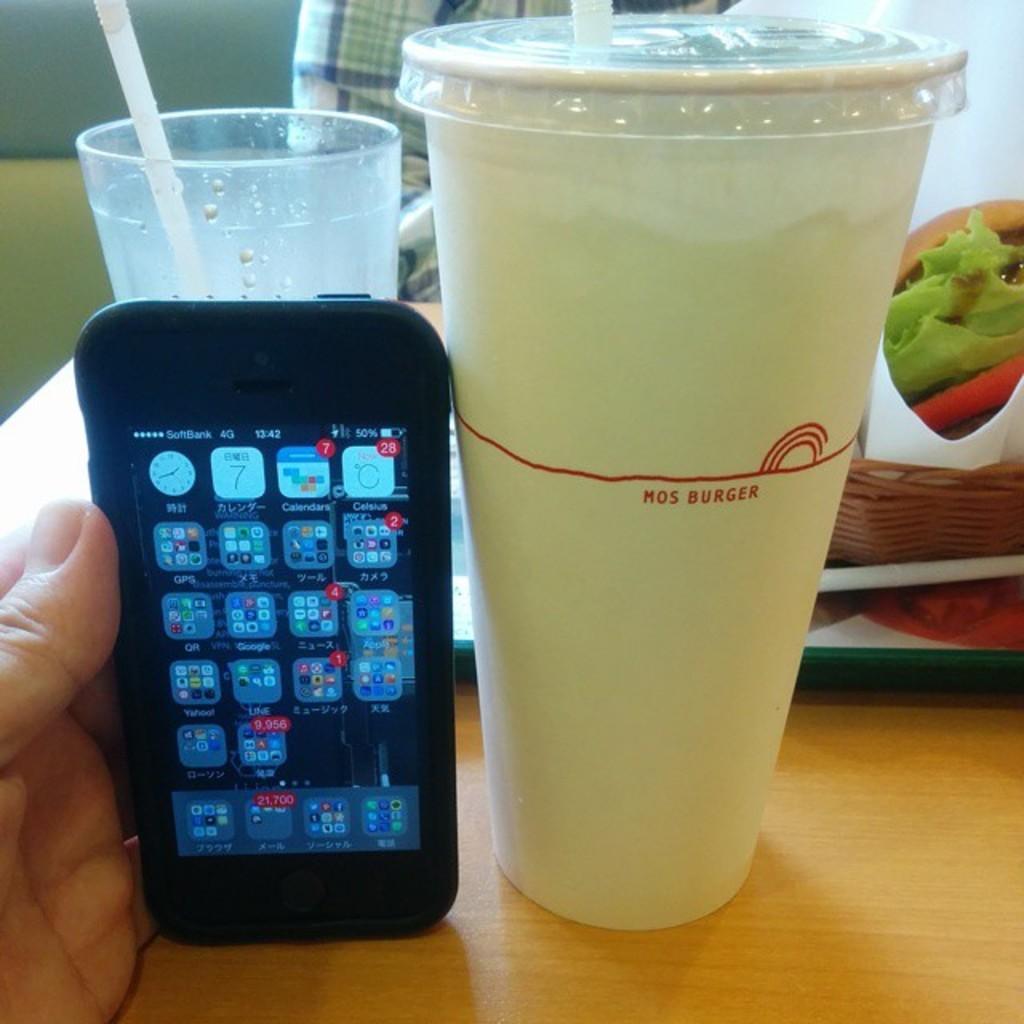Please provide a concise description of this image. In this image we can see some persons hand and that person is holding the mobile phone. We can also see the glasses with the straws. We can see some packet, basket and a tray on the table. In the background we can see the wall and also a person. 